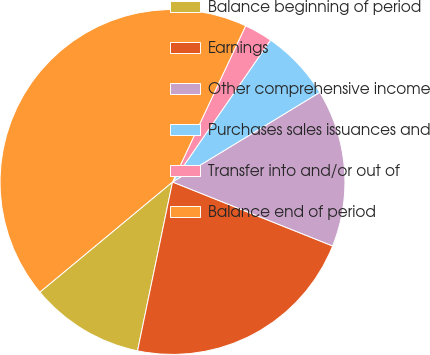Convert chart to OTSL. <chart><loc_0><loc_0><loc_500><loc_500><pie_chart><fcel>Balance beginning of period<fcel>Earnings<fcel>Other comprehensive income<fcel>Purchases sales issuances and<fcel>Transfer into and/or out of<fcel>Balance end of period<nl><fcel>10.72%<fcel>22.2%<fcel>14.75%<fcel>6.68%<fcel>2.65%<fcel>43.0%<nl></chart> 